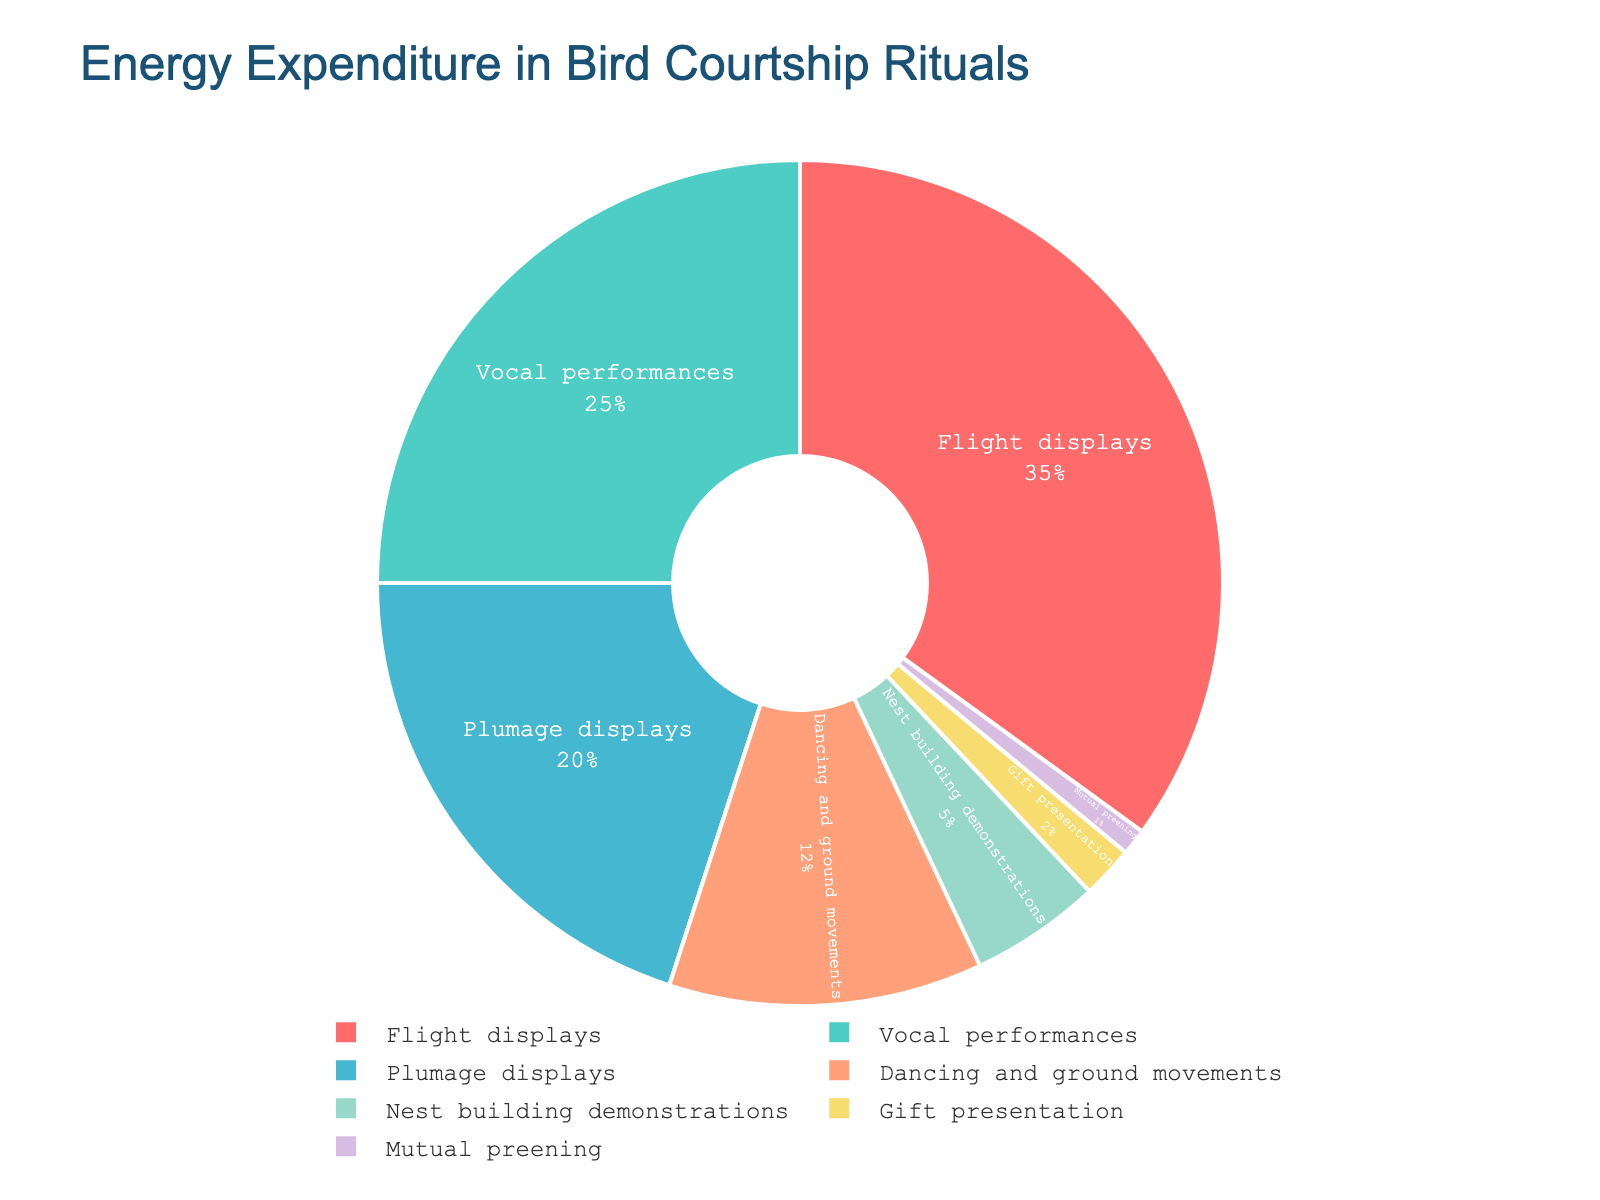What percentage of energy is spent on flight displays and vocal performances combined? The energy expenditure for flight displays is 35%, and for vocal performances, it is 25%. Adding them together gives 35% + 25% = 60%.
Answer: 60% Which ritual uses more energy, plumage displays or nest building demonstrations? The energy expenditure for plumage displays is 20%, while that for nest building demonstrations is 5%. Since 20% is greater than 5%, plumage displays use more energy.
Answer: Plumage displays Rank the rituals from the highest to the lowest energy expenditure. The percentages for each ritual are: Flight displays (35%), Vocal performances (25%), Plumage displays (20%), Dancing and ground movements (12%), Nest building demonstrations (5%), Gift presentation (2%), and Mutual preening (1%). Arranging these in descending order yields: Flight displays, Vocal performances, Plumage displays, Dancing and ground movements, Nest building demonstrations, Gift presentation, Mutual preening.
Answer: Flight displays, Vocal performances, Plumage displays, Dancing and ground movements, Nest building demonstrations, Gift presentation, Mutual preening Which rituals use less than 10% of energy individually? The rituals with percentages less than 10% are Nest building demonstrations (5%), Gift presentation (2%), and Mutual preening (1%).
Answer: Nest building demonstrations, Gift presentation, Mutual preening What fraction of the total energy is spent on dancing and ground movements and nest building demonstrations combined? The energy expenditure for dancing and ground movements is 12%, and for nest building demonstrations, it is 5%. Adding them together gives 12% + 5% = 17%.
Answer: 17% If the total energy is 1000 units, how many units are spent on gift presentation and mutual preening together? The percentage for gift presentation is 2%, and for mutual preening, it is 1%. The combined percentage is 2% + 1% = 3%. Therefore, 3% of 1000 units equals 3/100 * 1000 = 30 units.
Answer: 30 units How much more energy is spent on vocal performances than on plumage displays? The energy expenditure for vocal performances is 25%, and for plumage displays it is 20%. The difference is 25% - 20% = 5%.
Answer: 5% What is the average energy expenditure for the rituals? The total number of rituals is 7. Summing up the percentages: 35% (Flight displays) + 25% (Vocal performances) + 20% (Plumage displays) + 12% (Dancing and ground movements) + 5% (Nest building demonstrations) + 2% (Gift presentation) + 1% (Mutual preening) = 100%. The average is 100% / 7 ≈ 14.29%.
Answer: 14.29% Which ritual is represented with the smallest portion in the pie chart? The ritual using the least energy is Mutual preening with 1%.
Answer: Mutual preening 